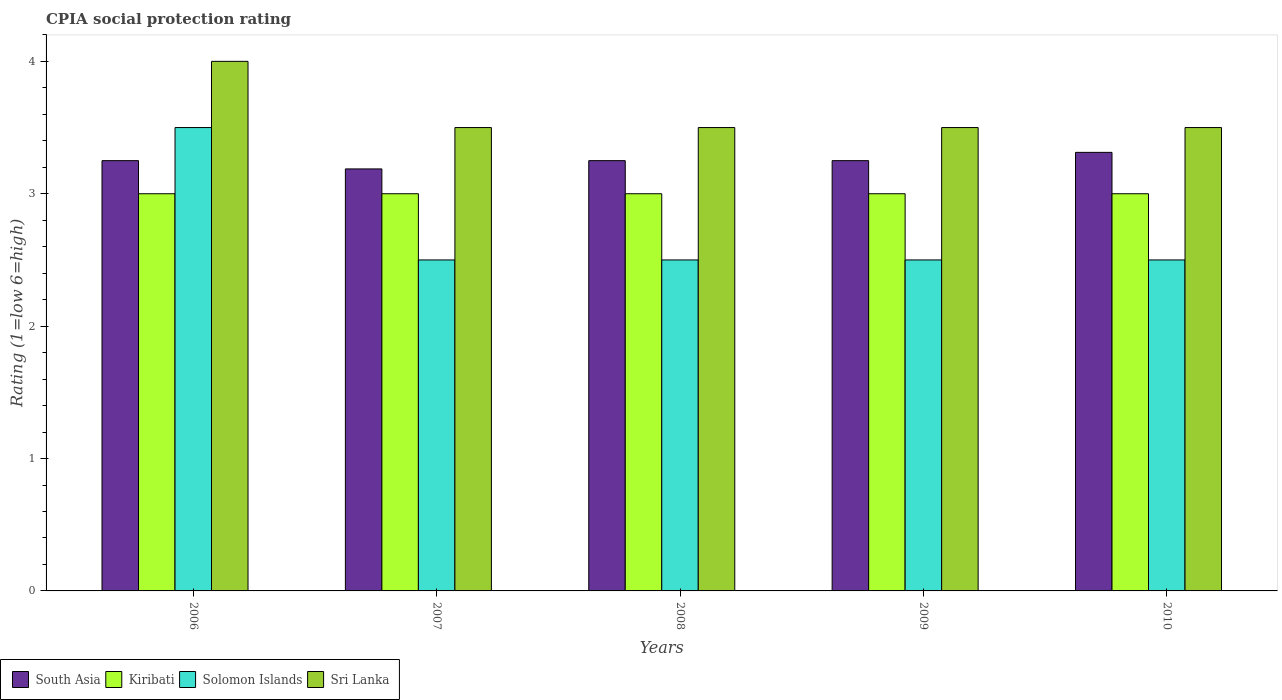Are the number of bars per tick equal to the number of legend labels?
Keep it short and to the point. Yes. Are the number of bars on each tick of the X-axis equal?
Ensure brevity in your answer.  Yes. What is the CPIA rating in South Asia in 2007?
Keep it short and to the point. 3.19. Across all years, what is the maximum CPIA rating in Sri Lanka?
Offer a very short reply. 4. Across all years, what is the minimum CPIA rating in South Asia?
Offer a terse response. 3.19. In which year was the CPIA rating in Kiribati maximum?
Provide a succinct answer. 2006. In which year was the CPIA rating in South Asia minimum?
Offer a very short reply. 2007. What is the total CPIA rating in Kiribati in the graph?
Your response must be concise. 15. What is the difference between the CPIA rating in Solomon Islands in 2010 and the CPIA rating in South Asia in 2006?
Your answer should be compact. -0.75. What is the average CPIA rating in Solomon Islands per year?
Make the answer very short. 2.7. In the year 2009, what is the difference between the CPIA rating in Kiribati and CPIA rating in Solomon Islands?
Your answer should be compact. 0.5. In how many years, is the CPIA rating in Sri Lanka greater than 0.2?
Make the answer very short. 5. Is the CPIA rating in South Asia in 2007 less than that in 2010?
Offer a terse response. Yes. What is the difference between the highest and the second highest CPIA rating in Solomon Islands?
Offer a very short reply. 1. Is it the case that in every year, the sum of the CPIA rating in Solomon Islands and CPIA rating in Kiribati is greater than the sum of CPIA rating in Sri Lanka and CPIA rating in South Asia?
Your answer should be compact. Yes. What does the 2nd bar from the left in 2008 represents?
Ensure brevity in your answer.  Kiribati. What does the 2nd bar from the right in 2007 represents?
Your answer should be very brief. Solomon Islands. Is it the case that in every year, the sum of the CPIA rating in Kiribati and CPIA rating in South Asia is greater than the CPIA rating in Solomon Islands?
Provide a succinct answer. Yes. How many years are there in the graph?
Give a very brief answer. 5. What is the difference between two consecutive major ticks on the Y-axis?
Your answer should be very brief. 1. Are the values on the major ticks of Y-axis written in scientific E-notation?
Give a very brief answer. No. Does the graph contain any zero values?
Keep it short and to the point. No. Where does the legend appear in the graph?
Provide a succinct answer. Bottom left. What is the title of the graph?
Offer a very short reply. CPIA social protection rating. Does "Estonia" appear as one of the legend labels in the graph?
Your response must be concise. No. What is the Rating (1=low 6=high) of South Asia in 2006?
Your response must be concise. 3.25. What is the Rating (1=low 6=high) of Solomon Islands in 2006?
Your answer should be compact. 3.5. What is the Rating (1=low 6=high) in Sri Lanka in 2006?
Your response must be concise. 4. What is the Rating (1=low 6=high) of South Asia in 2007?
Provide a short and direct response. 3.19. What is the Rating (1=low 6=high) of Solomon Islands in 2007?
Ensure brevity in your answer.  2.5. What is the Rating (1=low 6=high) of Solomon Islands in 2008?
Provide a short and direct response. 2.5. What is the Rating (1=low 6=high) of South Asia in 2009?
Your answer should be compact. 3.25. What is the Rating (1=low 6=high) of Sri Lanka in 2009?
Give a very brief answer. 3.5. What is the Rating (1=low 6=high) of South Asia in 2010?
Keep it short and to the point. 3.31. What is the Rating (1=low 6=high) of Kiribati in 2010?
Keep it short and to the point. 3. What is the Rating (1=low 6=high) of Solomon Islands in 2010?
Offer a terse response. 2.5. What is the Rating (1=low 6=high) in Sri Lanka in 2010?
Your answer should be very brief. 3.5. Across all years, what is the maximum Rating (1=low 6=high) in South Asia?
Offer a terse response. 3.31. Across all years, what is the maximum Rating (1=low 6=high) of Sri Lanka?
Make the answer very short. 4. Across all years, what is the minimum Rating (1=low 6=high) of South Asia?
Your answer should be compact. 3.19. Across all years, what is the minimum Rating (1=low 6=high) of Solomon Islands?
Offer a very short reply. 2.5. Across all years, what is the minimum Rating (1=low 6=high) in Sri Lanka?
Offer a very short reply. 3.5. What is the total Rating (1=low 6=high) in South Asia in the graph?
Provide a succinct answer. 16.25. What is the total Rating (1=low 6=high) in Sri Lanka in the graph?
Give a very brief answer. 18. What is the difference between the Rating (1=low 6=high) in South Asia in 2006 and that in 2007?
Your answer should be very brief. 0.06. What is the difference between the Rating (1=low 6=high) in Solomon Islands in 2006 and that in 2007?
Provide a short and direct response. 1. What is the difference between the Rating (1=low 6=high) of Sri Lanka in 2006 and that in 2007?
Offer a very short reply. 0.5. What is the difference between the Rating (1=low 6=high) of Kiribati in 2006 and that in 2008?
Provide a succinct answer. 0. What is the difference between the Rating (1=low 6=high) of Solomon Islands in 2006 and that in 2008?
Offer a very short reply. 1. What is the difference between the Rating (1=low 6=high) of Sri Lanka in 2006 and that in 2008?
Offer a very short reply. 0.5. What is the difference between the Rating (1=low 6=high) of South Asia in 2006 and that in 2009?
Ensure brevity in your answer.  0. What is the difference between the Rating (1=low 6=high) of Solomon Islands in 2006 and that in 2009?
Ensure brevity in your answer.  1. What is the difference between the Rating (1=low 6=high) in South Asia in 2006 and that in 2010?
Ensure brevity in your answer.  -0.06. What is the difference between the Rating (1=low 6=high) in South Asia in 2007 and that in 2008?
Ensure brevity in your answer.  -0.06. What is the difference between the Rating (1=low 6=high) of Sri Lanka in 2007 and that in 2008?
Make the answer very short. 0. What is the difference between the Rating (1=low 6=high) of South Asia in 2007 and that in 2009?
Keep it short and to the point. -0.06. What is the difference between the Rating (1=low 6=high) in Solomon Islands in 2007 and that in 2009?
Provide a short and direct response. 0. What is the difference between the Rating (1=low 6=high) in South Asia in 2007 and that in 2010?
Ensure brevity in your answer.  -0.12. What is the difference between the Rating (1=low 6=high) in Kiribati in 2007 and that in 2010?
Provide a short and direct response. 0. What is the difference between the Rating (1=low 6=high) of Sri Lanka in 2007 and that in 2010?
Make the answer very short. 0. What is the difference between the Rating (1=low 6=high) in Kiribati in 2008 and that in 2009?
Give a very brief answer. 0. What is the difference between the Rating (1=low 6=high) in Solomon Islands in 2008 and that in 2009?
Make the answer very short. 0. What is the difference between the Rating (1=low 6=high) of Sri Lanka in 2008 and that in 2009?
Offer a terse response. 0. What is the difference between the Rating (1=low 6=high) of South Asia in 2008 and that in 2010?
Offer a very short reply. -0.06. What is the difference between the Rating (1=low 6=high) in Kiribati in 2008 and that in 2010?
Ensure brevity in your answer.  0. What is the difference between the Rating (1=low 6=high) of Sri Lanka in 2008 and that in 2010?
Provide a succinct answer. 0. What is the difference between the Rating (1=low 6=high) of South Asia in 2009 and that in 2010?
Make the answer very short. -0.06. What is the difference between the Rating (1=low 6=high) in Kiribati in 2009 and that in 2010?
Offer a terse response. 0. What is the difference between the Rating (1=low 6=high) of Solomon Islands in 2009 and that in 2010?
Your response must be concise. 0. What is the difference between the Rating (1=low 6=high) in Solomon Islands in 2006 and the Rating (1=low 6=high) in Sri Lanka in 2007?
Your answer should be compact. 0. What is the difference between the Rating (1=low 6=high) of South Asia in 2006 and the Rating (1=low 6=high) of Solomon Islands in 2008?
Provide a short and direct response. 0.75. What is the difference between the Rating (1=low 6=high) in Kiribati in 2006 and the Rating (1=low 6=high) in Sri Lanka in 2008?
Your answer should be very brief. -0.5. What is the difference between the Rating (1=low 6=high) of Solomon Islands in 2006 and the Rating (1=low 6=high) of Sri Lanka in 2008?
Give a very brief answer. 0. What is the difference between the Rating (1=low 6=high) in South Asia in 2006 and the Rating (1=low 6=high) in Kiribati in 2009?
Your answer should be compact. 0.25. What is the difference between the Rating (1=low 6=high) in South Asia in 2006 and the Rating (1=low 6=high) in Solomon Islands in 2009?
Offer a very short reply. 0.75. What is the difference between the Rating (1=low 6=high) of South Asia in 2006 and the Rating (1=low 6=high) of Sri Lanka in 2009?
Make the answer very short. -0.25. What is the difference between the Rating (1=low 6=high) of Kiribati in 2006 and the Rating (1=low 6=high) of Solomon Islands in 2009?
Provide a succinct answer. 0.5. What is the difference between the Rating (1=low 6=high) of South Asia in 2006 and the Rating (1=low 6=high) of Kiribati in 2010?
Make the answer very short. 0.25. What is the difference between the Rating (1=low 6=high) of South Asia in 2007 and the Rating (1=low 6=high) of Kiribati in 2008?
Make the answer very short. 0.19. What is the difference between the Rating (1=low 6=high) of South Asia in 2007 and the Rating (1=low 6=high) of Solomon Islands in 2008?
Keep it short and to the point. 0.69. What is the difference between the Rating (1=low 6=high) of South Asia in 2007 and the Rating (1=low 6=high) of Sri Lanka in 2008?
Your response must be concise. -0.31. What is the difference between the Rating (1=low 6=high) in Kiribati in 2007 and the Rating (1=low 6=high) in Solomon Islands in 2008?
Your answer should be very brief. 0.5. What is the difference between the Rating (1=low 6=high) of Solomon Islands in 2007 and the Rating (1=low 6=high) of Sri Lanka in 2008?
Ensure brevity in your answer.  -1. What is the difference between the Rating (1=low 6=high) of South Asia in 2007 and the Rating (1=low 6=high) of Kiribati in 2009?
Make the answer very short. 0.19. What is the difference between the Rating (1=low 6=high) in South Asia in 2007 and the Rating (1=low 6=high) in Solomon Islands in 2009?
Ensure brevity in your answer.  0.69. What is the difference between the Rating (1=low 6=high) in South Asia in 2007 and the Rating (1=low 6=high) in Sri Lanka in 2009?
Give a very brief answer. -0.31. What is the difference between the Rating (1=low 6=high) in Kiribati in 2007 and the Rating (1=low 6=high) in Sri Lanka in 2009?
Provide a succinct answer. -0.5. What is the difference between the Rating (1=low 6=high) in Solomon Islands in 2007 and the Rating (1=low 6=high) in Sri Lanka in 2009?
Provide a short and direct response. -1. What is the difference between the Rating (1=low 6=high) in South Asia in 2007 and the Rating (1=low 6=high) in Kiribati in 2010?
Your answer should be compact. 0.19. What is the difference between the Rating (1=low 6=high) in South Asia in 2007 and the Rating (1=low 6=high) in Solomon Islands in 2010?
Keep it short and to the point. 0.69. What is the difference between the Rating (1=low 6=high) of South Asia in 2007 and the Rating (1=low 6=high) of Sri Lanka in 2010?
Offer a very short reply. -0.31. What is the difference between the Rating (1=low 6=high) in South Asia in 2008 and the Rating (1=low 6=high) in Solomon Islands in 2009?
Your response must be concise. 0.75. What is the difference between the Rating (1=low 6=high) in South Asia in 2008 and the Rating (1=low 6=high) in Sri Lanka in 2009?
Your answer should be compact. -0.25. What is the difference between the Rating (1=low 6=high) in Kiribati in 2008 and the Rating (1=low 6=high) in Sri Lanka in 2009?
Give a very brief answer. -0.5. What is the difference between the Rating (1=low 6=high) in Solomon Islands in 2008 and the Rating (1=low 6=high) in Sri Lanka in 2009?
Ensure brevity in your answer.  -1. What is the difference between the Rating (1=low 6=high) of Kiribati in 2008 and the Rating (1=low 6=high) of Solomon Islands in 2010?
Provide a short and direct response. 0.5. What is the difference between the Rating (1=low 6=high) of Kiribati in 2008 and the Rating (1=low 6=high) of Sri Lanka in 2010?
Offer a terse response. -0.5. What is the difference between the Rating (1=low 6=high) of South Asia in 2009 and the Rating (1=low 6=high) of Kiribati in 2010?
Make the answer very short. 0.25. What is the difference between the Rating (1=low 6=high) in South Asia in 2009 and the Rating (1=low 6=high) in Solomon Islands in 2010?
Provide a short and direct response. 0.75. What is the difference between the Rating (1=low 6=high) of Kiribati in 2009 and the Rating (1=low 6=high) of Solomon Islands in 2010?
Keep it short and to the point. 0.5. What is the average Rating (1=low 6=high) of South Asia per year?
Give a very brief answer. 3.25. What is the average Rating (1=low 6=high) in Kiribati per year?
Offer a very short reply. 3. What is the average Rating (1=low 6=high) of Solomon Islands per year?
Keep it short and to the point. 2.7. What is the average Rating (1=low 6=high) in Sri Lanka per year?
Ensure brevity in your answer.  3.6. In the year 2006, what is the difference between the Rating (1=low 6=high) in South Asia and Rating (1=low 6=high) in Kiribati?
Offer a terse response. 0.25. In the year 2006, what is the difference between the Rating (1=low 6=high) of South Asia and Rating (1=low 6=high) of Sri Lanka?
Make the answer very short. -0.75. In the year 2007, what is the difference between the Rating (1=low 6=high) of South Asia and Rating (1=low 6=high) of Kiribati?
Offer a very short reply. 0.19. In the year 2007, what is the difference between the Rating (1=low 6=high) in South Asia and Rating (1=low 6=high) in Solomon Islands?
Offer a very short reply. 0.69. In the year 2007, what is the difference between the Rating (1=low 6=high) in South Asia and Rating (1=low 6=high) in Sri Lanka?
Provide a succinct answer. -0.31. In the year 2008, what is the difference between the Rating (1=low 6=high) in South Asia and Rating (1=low 6=high) in Kiribati?
Your answer should be very brief. 0.25. In the year 2008, what is the difference between the Rating (1=low 6=high) of Kiribati and Rating (1=low 6=high) of Solomon Islands?
Give a very brief answer. 0.5. In the year 2008, what is the difference between the Rating (1=low 6=high) in Kiribati and Rating (1=low 6=high) in Sri Lanka?
Give a very brief answer. -0.5. In the year 2008, what is the difference between the Rating (1=low 6=high) in Solomon Islands and Rating (1=low 6=high) in Sri Lanka?
Make the answer very short. -1. In the year 2009, what is the difference between the Rating (1=low 6=high) in Kiribati and Rating (1=low 6=high) in Solomon Islands?
Provide a succinct answer. 0.5. In the year 2010, what is the difference between the Rating (1=low 6=high) in South Asia and Rating (1=low 6=high) in Kiribati?
Your response must be concise. 0.31. In the year 2010, what is the difference between the Rating (1=low 6=high) of South Asia and Rating (1=low 6=high) of Solomon Islands?
Make the answer very short. 0.81. In the year 2010, what is the difference between the Rating (1=low 6=high) of South Asia and Rating (1=low 6=high) of Sri Lanka?
Offer a terse response. -0.19. In the year 2010, what is the difference between the Rating (1=low 6=high) of Solomon Islands and Rating (1=low 6=high) of Sri Lanka?
Offer a very short reply. -1. What is the ratio of the Rating (1=low 6=high) in South Asia in 2006 to that in 2007?
Ensure brevity in your answer.  1.02. What is the ratio of the Rating (1=low 6=high) in Kiribati in 2006 to that in 2007?
Your response must be concise. 1. What is the ratio of the Rating (1=low 6=high) of Sri Lanka in 2006 to that in 2007?
Make the answer very short. 1.14. What is the ratio of the Rating (1=low 6=high) in South Asia in 2006 to that in 2008?
Offer a terse response. 1. What is the ratio of the Rating (1=low 6=high) of Kiribati in 2006 to that in 2008?
Provide a short and direct response. 1. What is the ratio of the Rating (1=low 6=high) of South Asia in 2006 to that in 2009?
Keep it short and to the point. 1. What is the ratio of the Rating (1=low 6=high) of South Asia in 2006 to that in 2010?
Your response must be concise. 0.98. What is the ratio of the Rating (1=low 6=high) in South Asia in 2007 to that in 2008?
Offer a very short reply. 0.98. What is the ratio of the Rating (1=low 6=high) of Kiribati in 2007 to that in 2008?
Ensure brevity in your answer.  1. What is the ratio of the Rating (1=low 6=high) of Solomon Islands in 2007 to that in 2008?
Provide a succinct answer. 1. What is the ratio of the Rating (1=low 6=high) in South Asia in 2007 to that in 2009?
Provide a succinct answer. 0.98. What is the ratio of the Rating (1=low 6=high) in Solomon Islands in 2007 to that in 2009?
Keep it short and to the point. 1. What is the ratio of the Rating (1=low 6=high) of South Asia in 2007 to that in 2010?
Offer a terse response. 0.96. What is the ratio of the Rating (1=low 6=high) in Sri Lanka in 2007 to that in 2010?
Provide a succinct answer. 1. What is the ratio of the Rating (1=low 6=high) in South Asia in 2008 to that in 2009?
Ensure brevity in your answer.  1. What is the ratio of the Rating (1=low 6=high) of Solomon Islands in 2008 to that in 2009?
Give a very brief answer. 1. What is the ratio of the Rating (1=low 6=high) in Sri Lanka in 2008 to that in 2009?
Your answer should be very brief. 1. What is the ratio of the Rating (1=low 6=high) of South Asia in 2008 to that in 2010?
Offer a very short reply. 0.98. What is the ratio of the Rating (1=low 6=high) of Kiribati in 2008 to that in 2010?
Give a very brief answer. 1. What is the ratio of the Rating (1=low 6=high) of Solomon Islands in 2008 to that in 2010?
Keep it short and to the point. 1. What is the ratio of the Rating (1=low 6=high) of Sri Lanka in 2008 to that in 2010?
Offer a very short reply. 1. What is the ratio of the Rating (1=low 6=high) in South Asia in 2009 to that in 2010?
Provide a short and direct response. 0.98. What is the difference between the highest and the second highest Rating (1=low 6=high) in South Asia?
Ensure brevity in your answer.  0.06. What is the difference between the highest and the second highest Rating (1=low 6=high) in Sri Lanka?
Your answer should be very brief. 0.5. What is the difference between the highest and the lowest Rating (1=low 6=high) of South Asia?
Provide a short and direct response. 0.12. What is the difference between the highest and the lowest Rating (1=low 6=high) of Solomon Islands?
Offer a terse response. 1. 